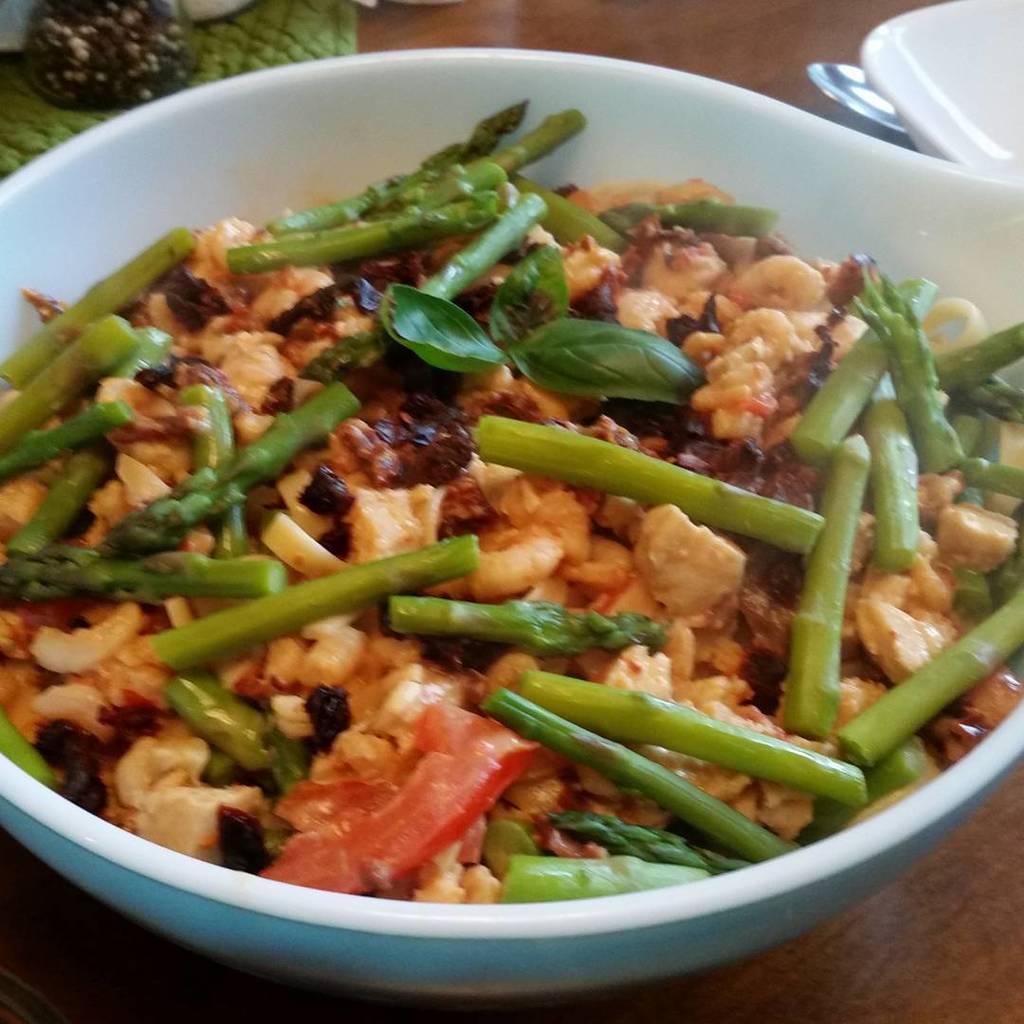Can you describe this image briefly? In this image we can see a serving bowl which consists of food in it and is placed on the table. 